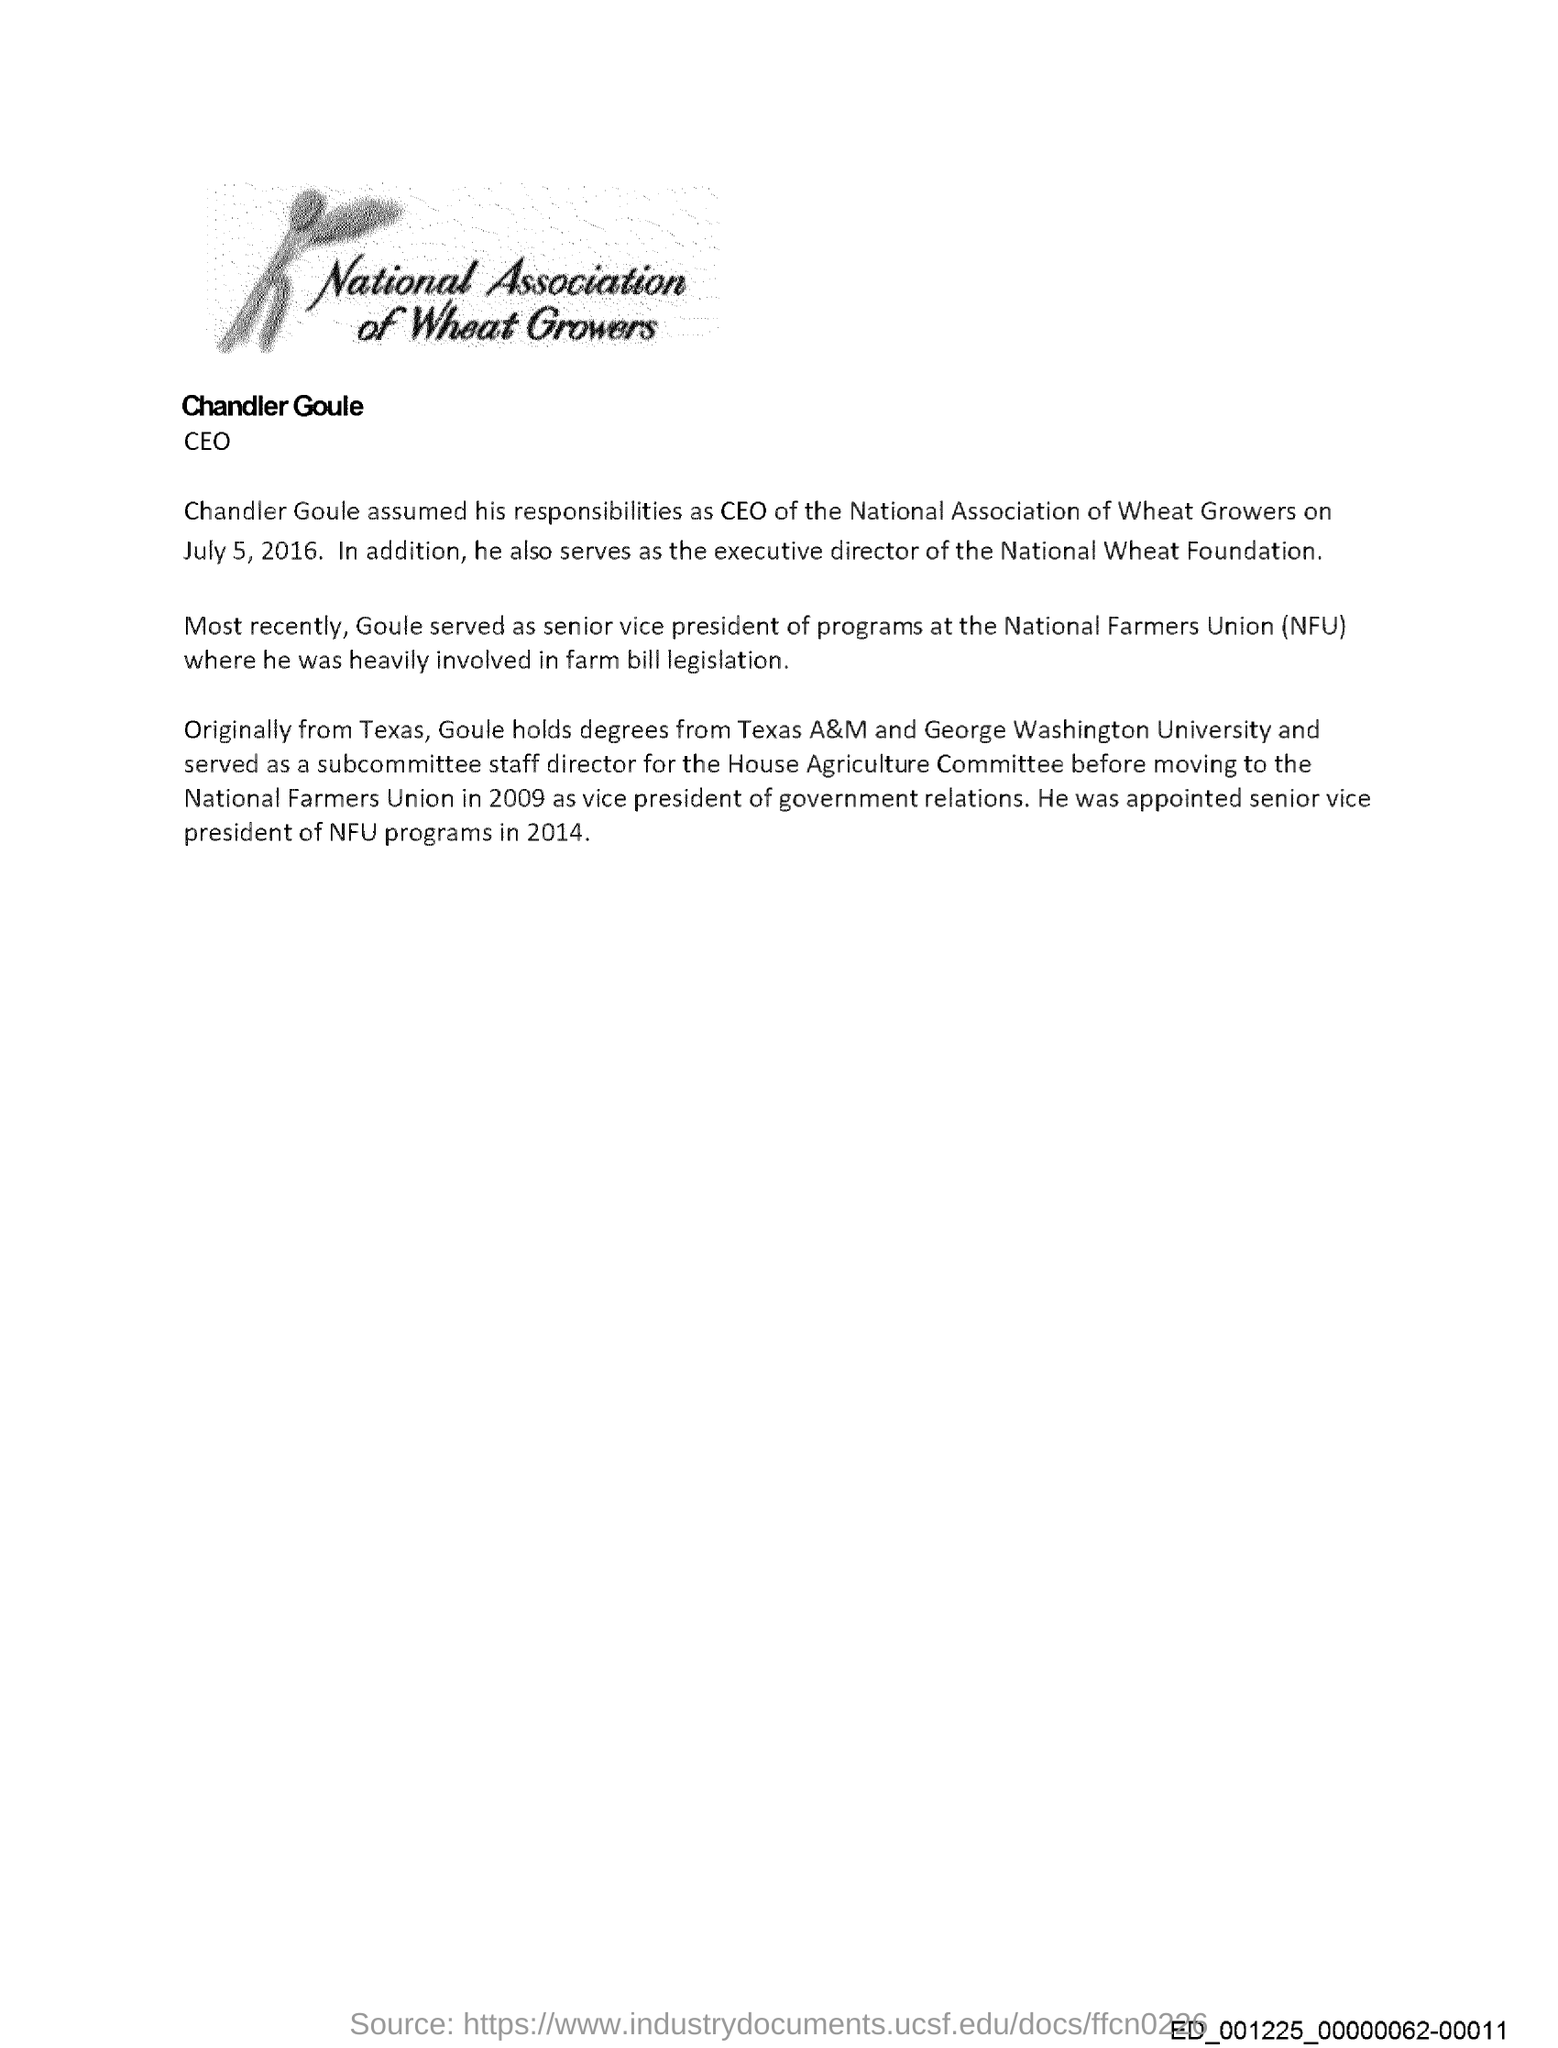Who is the ceo of national association of wheat growers?
Give a very brief answer. Chandler Goule. When did Chandler Goule assume his responsibilities as CEO?
Give a very brief answer. July 5, 2016. What was Chandler Goule's position in national wheat foundation?
Offer a very short reply. Executive Director. Earlier where did Goule worked as senior vice president of programs?
Offer a very short reply. At National Farmers Union. What is NFU?
Your response must be concise. National Farmers Union. Where does Goule hail from?
Your answer should be very brief. Texas. Where does Goule holds degree from?
Keep it short and to the point. Texas A&M and George Washington University. When was he appointed as senior vice president of NFU programs?
Your answer should be very brief. 2014. 